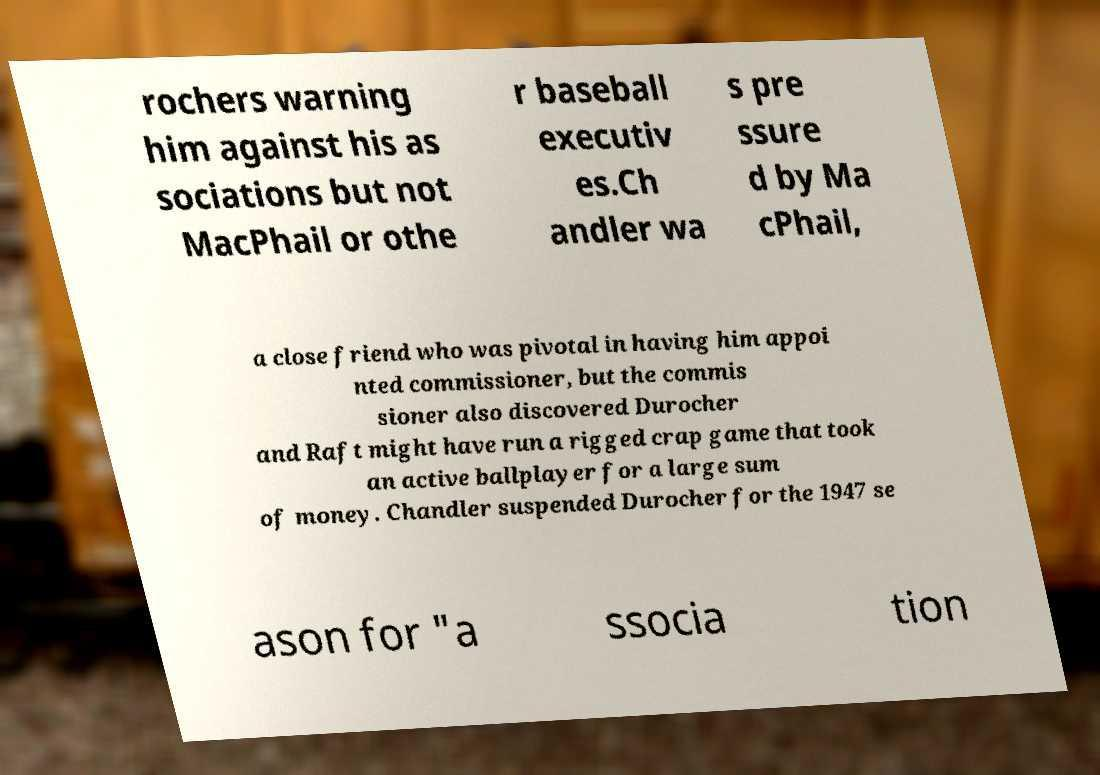I need the written content from this picture converted into text. Can you do that? rochers warning him against his as sociations but not MacPhail or othe r baseball executiv es.Ch andler wa s pre ssure d by Ma cPhail, a close friend who was pivotal in having him appoi nted commissioner, but the commis sioner also discovered Durocher and Raft might have run a rigged crap game that took an active ballplayer for a large sum of money. Chandler suspended Durocher for the 1947 se ason for "a ssocia tion 